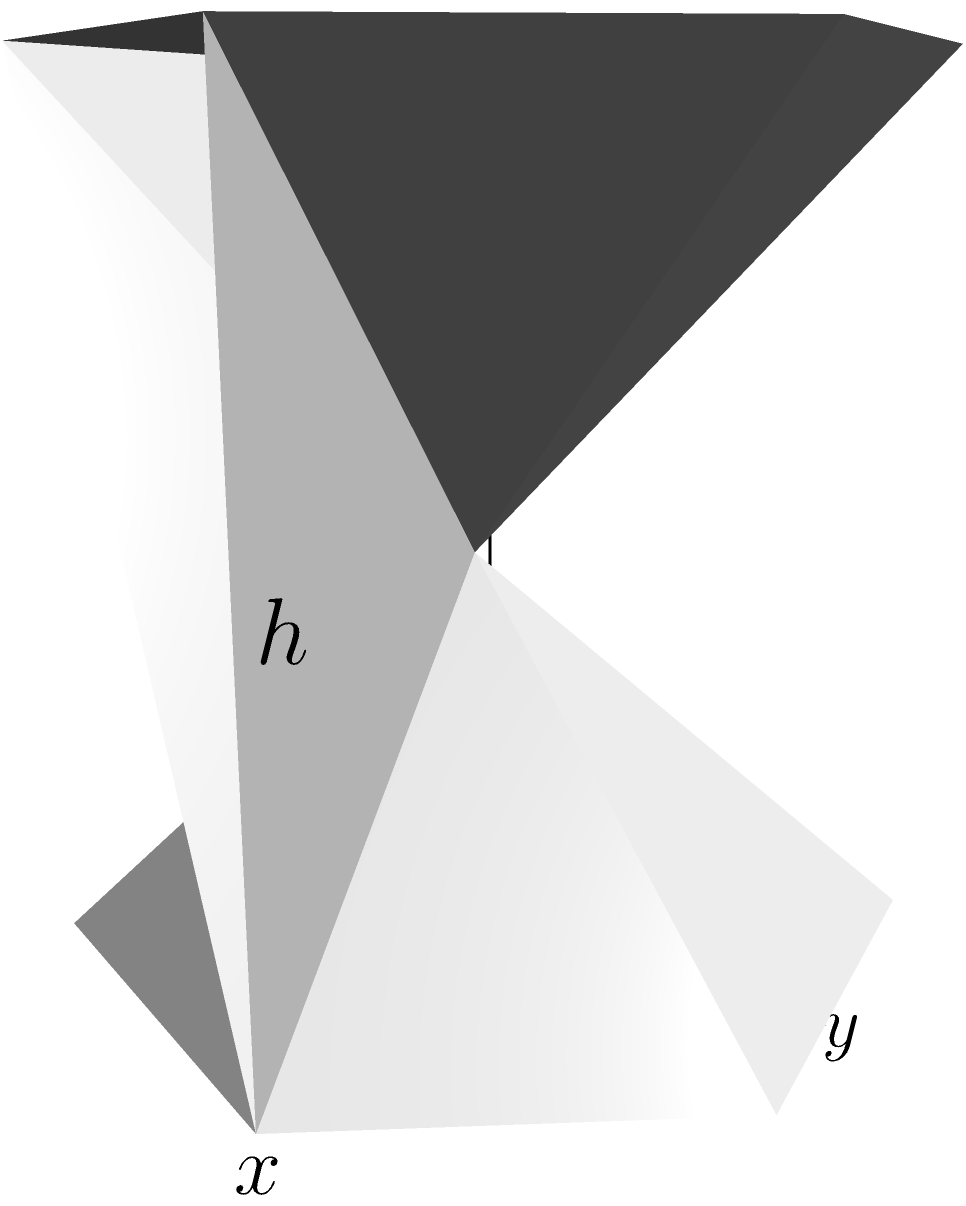You are creating a honeycomb-inspired hexagonal prism sculpture using beeswax. The hexagonal base has a side length of $a = 2$ cm, and the height of the prism is $h = 4$ cm. Calculate the total surface area of the sculpture, including both hexagonal bases and all rectangular sides. To calculate the total surface area of the hexagonal prism, we need to find the area of the two hexagonal bases and the area of the six rectangular sides, then sum them up.

Step 1: Calculate the area of one hexagonal base.
The area of a regular hexagon is given by $A_{\text{hex}} = \frac{3\sqrt{3}}{2}a^2$
$A_{\text{hex}} = \frac{3\sqrt{3}}{2}(2)^2 = 6\sqrt{3} \approx 10.39$ cm²

Step 2: Calculate the area of one rectangular side.
The width of each rectangle is the side length of the hexagon ($a$), and the height is the height of the prism ($h$).
$A_{\text{rect}} = a \times h = 2 \times 4 = 8$ cm²

Step 3: Calculate the total surface area.
Total surface area = Area of 2 hexagonal bases + Area of 6 rectangular sides
$SA_{\text{total}} = 2A_{\text{hex}} + 6A_{\text{rect}}$
$SA_{\text{total}} = 2(6\sqrt{3}) + 6(8)$
$SA_{\text{total}} = 12\sqrt{3} + 48$

Step 4: Simplify the expression.
$SA_{\text{total}} = 12\sqrt{3} + 48 \approx 68.78$ cm²
Answer: $12\sqrt{3} + 48$ cm² 